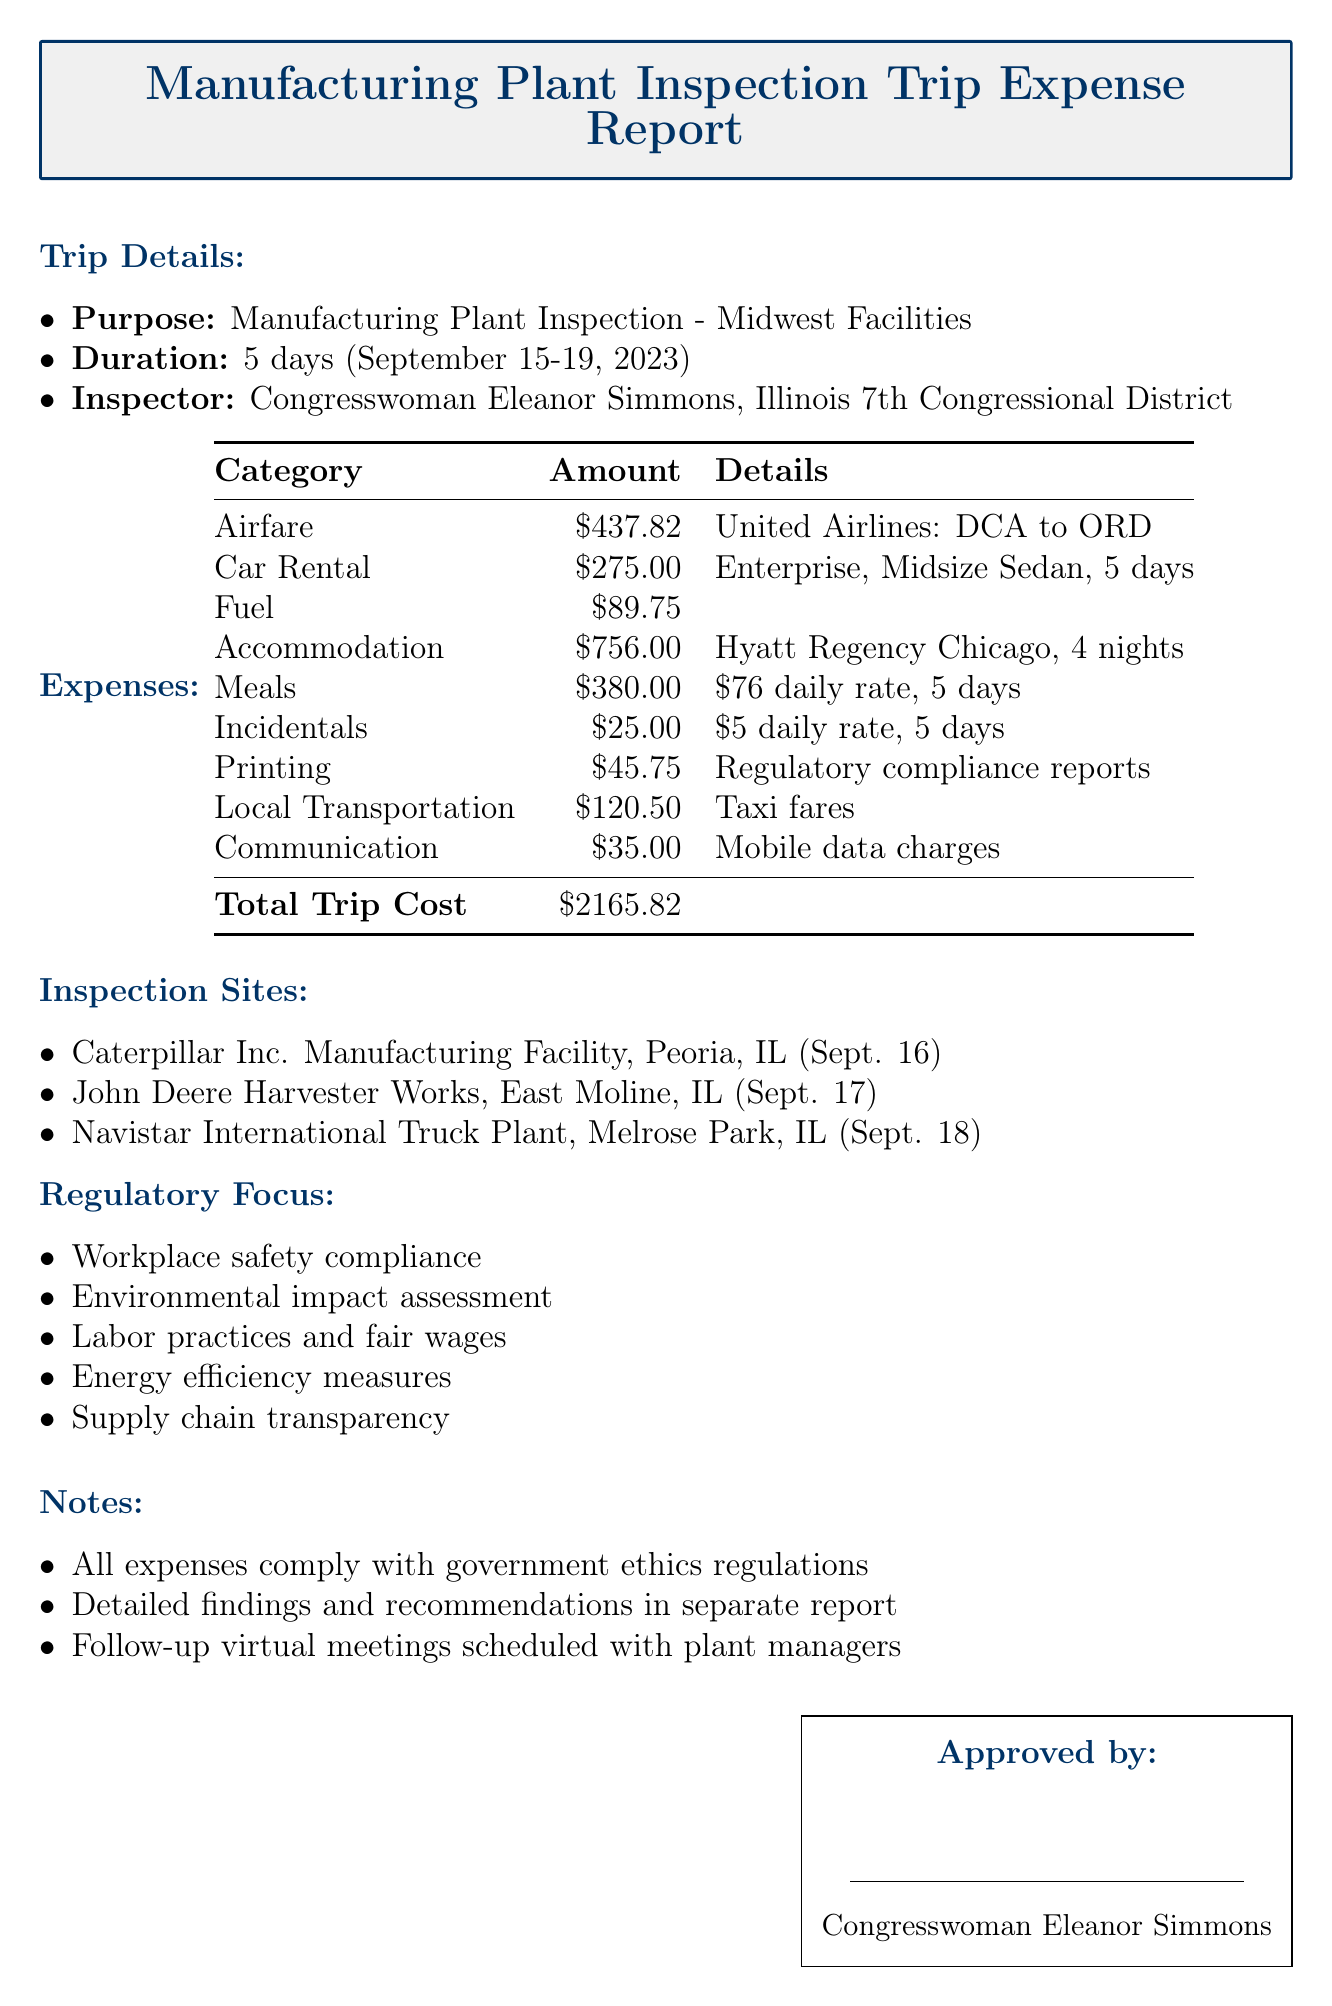What was the total trip cost? The total trip cost is explicitly stated in the document.
Answer: $2165.82 Who is the inspector for the trip? The document lists the inspector's name under trip details.
Answer: Congresswoman Eleanor Simmons What hotel was used for accommodations? The document specifies the name of the hotel in the accommodations section.
Answer: Hyatt Regency Chicago How many inspection sites were visited? The number of inspection sites is counted from the list provided in the inspection sites section.
Answer: 3 What was the daily meal allowance? The daily meal allowance is mentioned within the per diem section and is a specific rate.
Answer: $76.00 Which company provided the car rental? The document specifies the company name in the travel expenses section.
Answer: Enterprise Rent-A-Car What date was the Caterpillar Inc. Manufacturing Facility visited? The visit date for this inspection site is mentioned specifically in the document.
Answer: September 16, 2023 What is one of the focuses of the regulatory inspection? The document lists multiple areas of regulatory focus; any one of them is acceptable as an answer.
Answer: Workplace safety compliance What was the cumulative cost of local transportation? The document states the cost of local transportation in the additional expenses section.
Answer: $120.50 